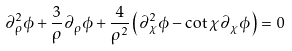Convert formula to latex. <formula><loc_0><loc_0><loc_500><loc_500>\partial _ { \rho } ^ { 2 } \phi + \frac { 3 } { \rho } \partial _ { \rho } \phi + \frac { 4 } { \rho ^ { 2 } } \left ( \partial _ { \chi } ^ { 2 } \phi - \cot { \chi } \partial _ { \chi } \phi \right ) = 0</formula> 